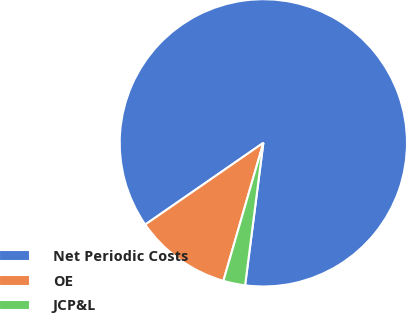Convert chart to OTSL. <chart><loc_0><loc_0><loc_500><loc_500><pie_chart><fcel>Net Periodic Costs<fcel>OE<fcel>JCP&L<nl><fcel>86.67%<fcel>10.88%<fcel>2.46%<nl></chart> 